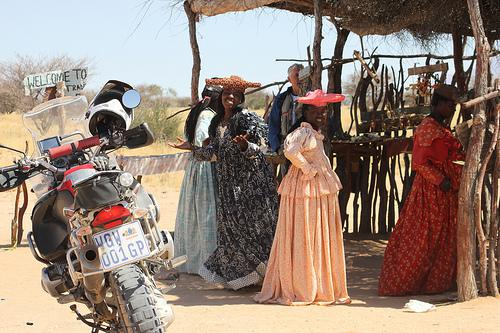Question: why is it bright?
Choices:
A. The sun is shining.
B. The light's are blinding.
C. The huge bondfire.
D. The camera's are flashing.
Answer with the letter. Answer: A Question: what are the women wearing?
Choices:
A. Skirts.
B. Dresses.
C. Skorts.
D. Shorts.
Answer with the letter. Answer: B Question: what is on the ground?
Choices:
A. Sand.
B. Pavement.
C. Gravel.
D. Dirt.
Answer with the letter. Answer: D Question: how is the bike standing?
Choices:
A. On its side.
B. On its kickstand.
C. On the wall.
D. On the bike rack.
Answer with the letter. Answer: B Question: who wears hats?
Choices:
A. The women.
B. The men.
C. The dancers.
D. The children.
Answer with the letter. Answer: A 